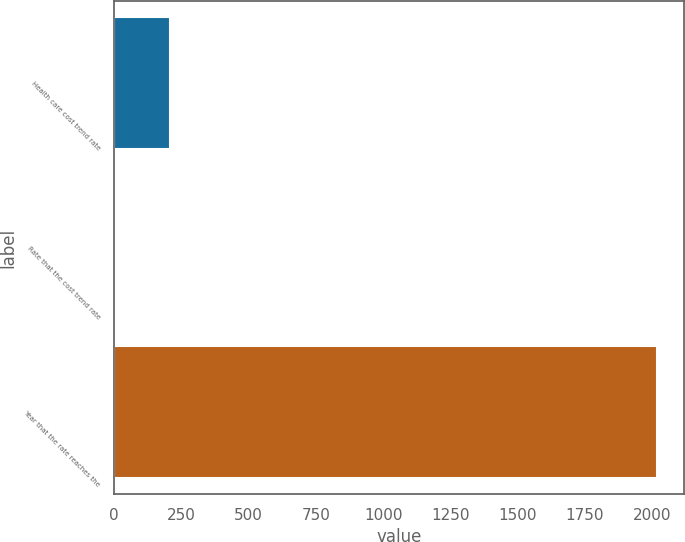Convert chart. <chart><loc_0><loc_0><loc_500><loc_500><bar_chart><fcel>Health care cost trend rate<fcel>Rate that the cost trend rate<fcel>Year that the rate reaches the<nl><fcel>206.2<fcel>5<fcel>2017<nl></chart> 